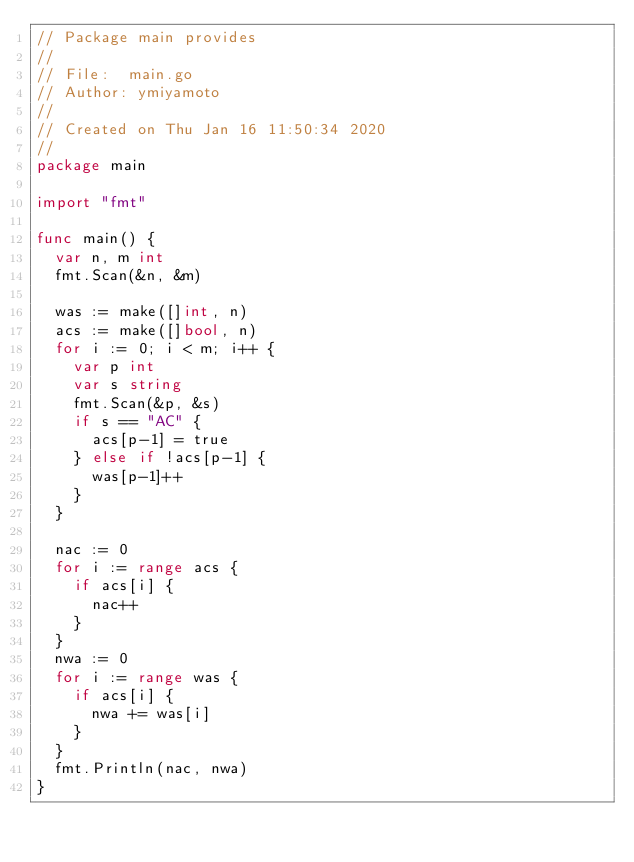Convert code to text. <code><loc_0><loc_0><loc_500><loc_500><_Go_>// Package main provides
//
// File:  main.go
// Author: ymiyamoto
//
// Created on Thu Jan 16 11:50:34 2020
//
package main

import "fmt"

func main() {
	var n, m int
	fmt.Scan(&n, &m)

	was := make([]int, n)
	acs := make([]bool, n)
	for i := 0; i < m; i++ {
		var p int
		var s string
		fmt.Scan(&p, &s)
		if s == "AC" {
			acs[p-1] = true
		} else if !acs[p-1] {
			was[p-1]++
		}
	}

	nac := 0
	for i := range acs {
		if acs[i] {
			nac++
		}
	}
	nwa := 0
	for i := range was {
		if acs[i] {
			nwa += was[i]
		}
	}
	fmt.Println(nac, nwa)
}
</code> 